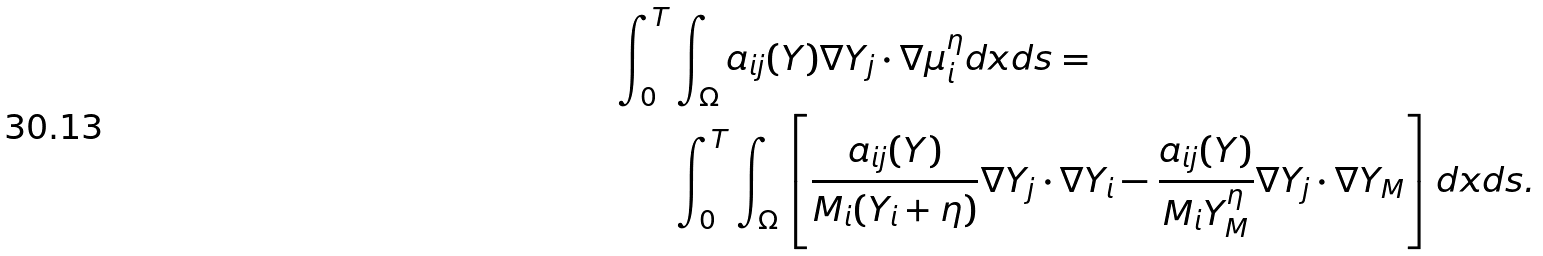<formula> <loc_0><loc_0><loc_500><loc_500>\int _ { 0 } ^ { T } & \int _ { \Omega } a _ { i j } ( Y ) \nabla Y _ { j } \cdot \nabla \mu ^ { \eta } _ { i } d x d s = \\ & \int _ { 0 } ^ { T } \int _ { \Omega } \left [ \frac { a _ { i j } ( Y ) } { M _ { i } ( Y _ { i } + \eta ) } \nabla Y _ { j } \cdot \nabla Y _ { i } - \frac { a _ { i j } ( Y ) } { M _ { i } Y ^ { \eta } _ { M } } \nabla Y _ { j } \cdot \nabla Y _ { M } \right ] d x d s .</formula> 